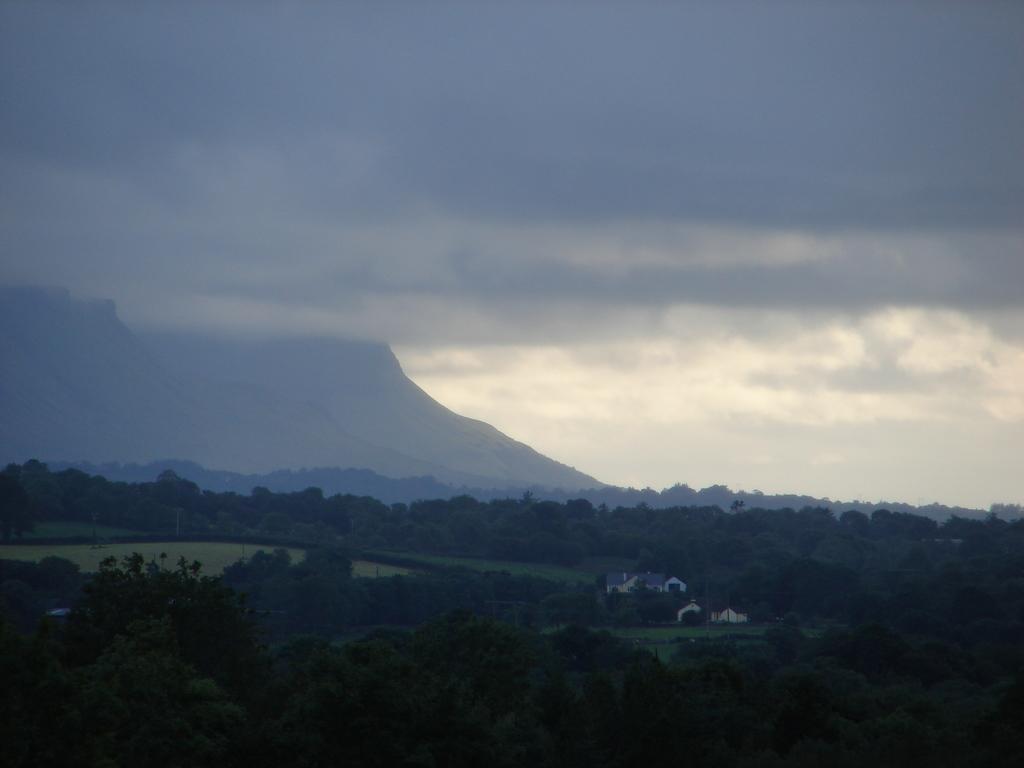Can you describe this image briefly? In this image we can see trees, mountains, houses, also we can see the sky. 